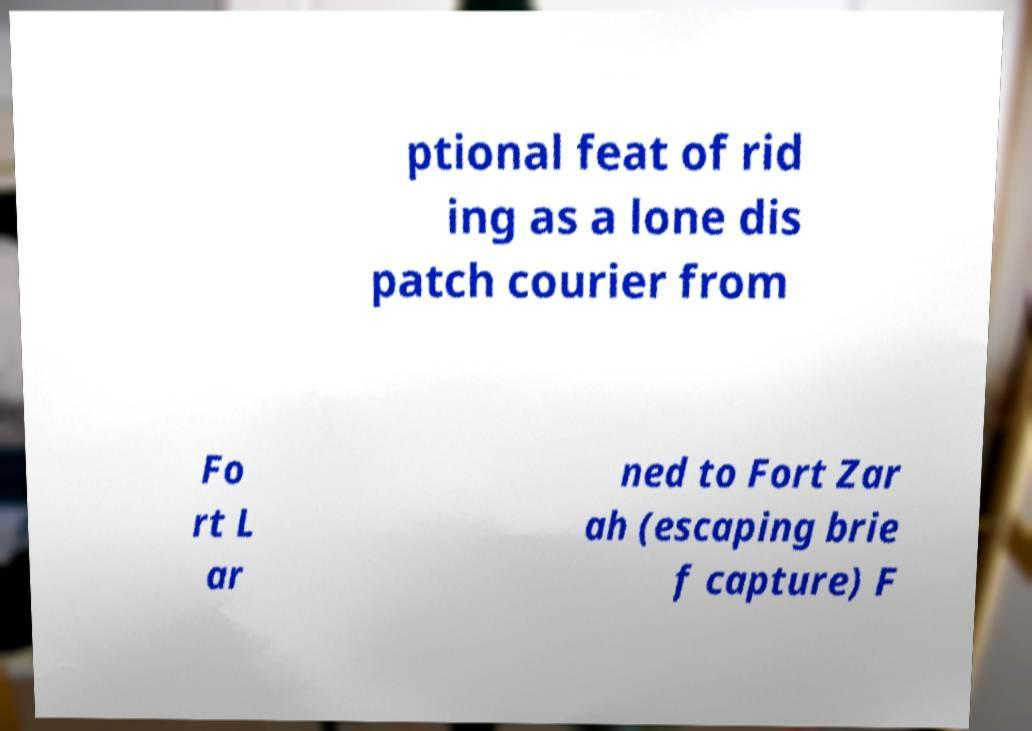What messages or text are displayed in this image? I need them in a readable, typed format. ptional feat of rid ing as a lone dis patch courier from Fo rt L ar ned to Fort Zar ah (escaping brie f capture) F 